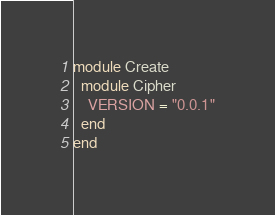<code> <loc_0><loc_0><loc_500><loc_500><_Ruby_>module Create
  module Cipher
    VERSION = "0.0.1"
  end
end
</code> 